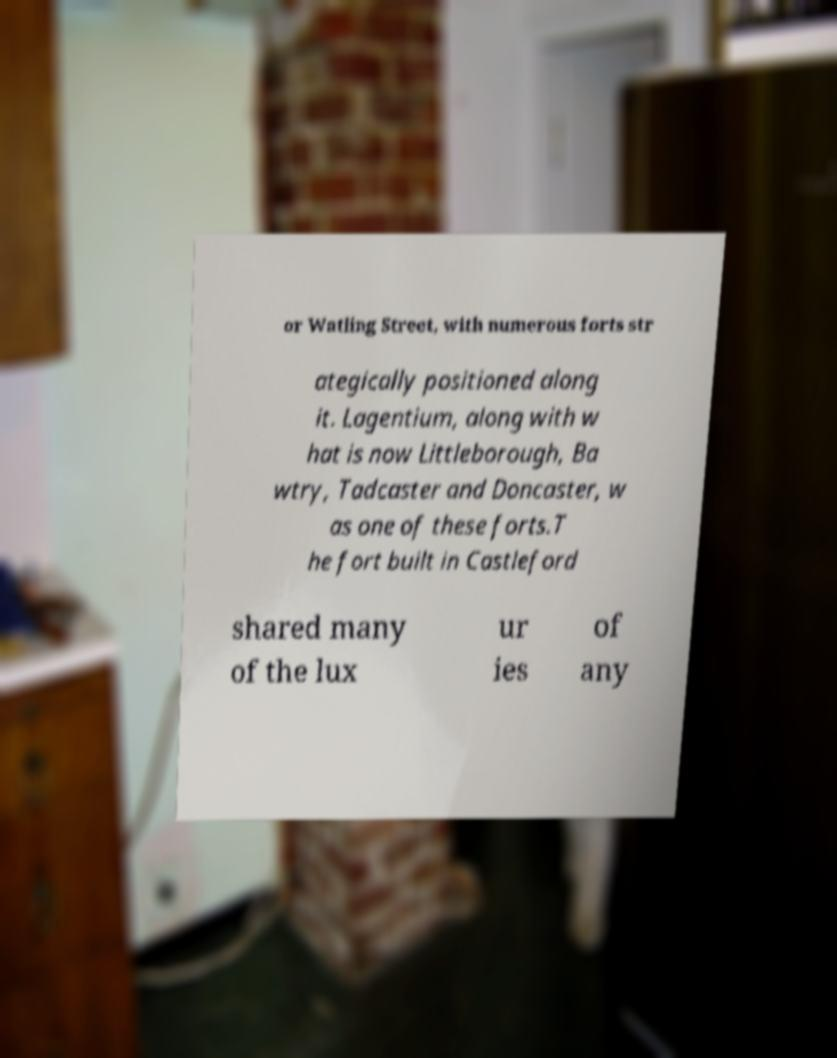Can you accurately transcribe the text from the provided image for me? or Watling Street, with numerous forts str ategically positioned along it. Lagentium, along with w hat is now Littleborough, Ba wtry, Tadcaster and Doncaster, w as one of these forts.T he fort built in Castleford shared many of the lux ur ies of any 